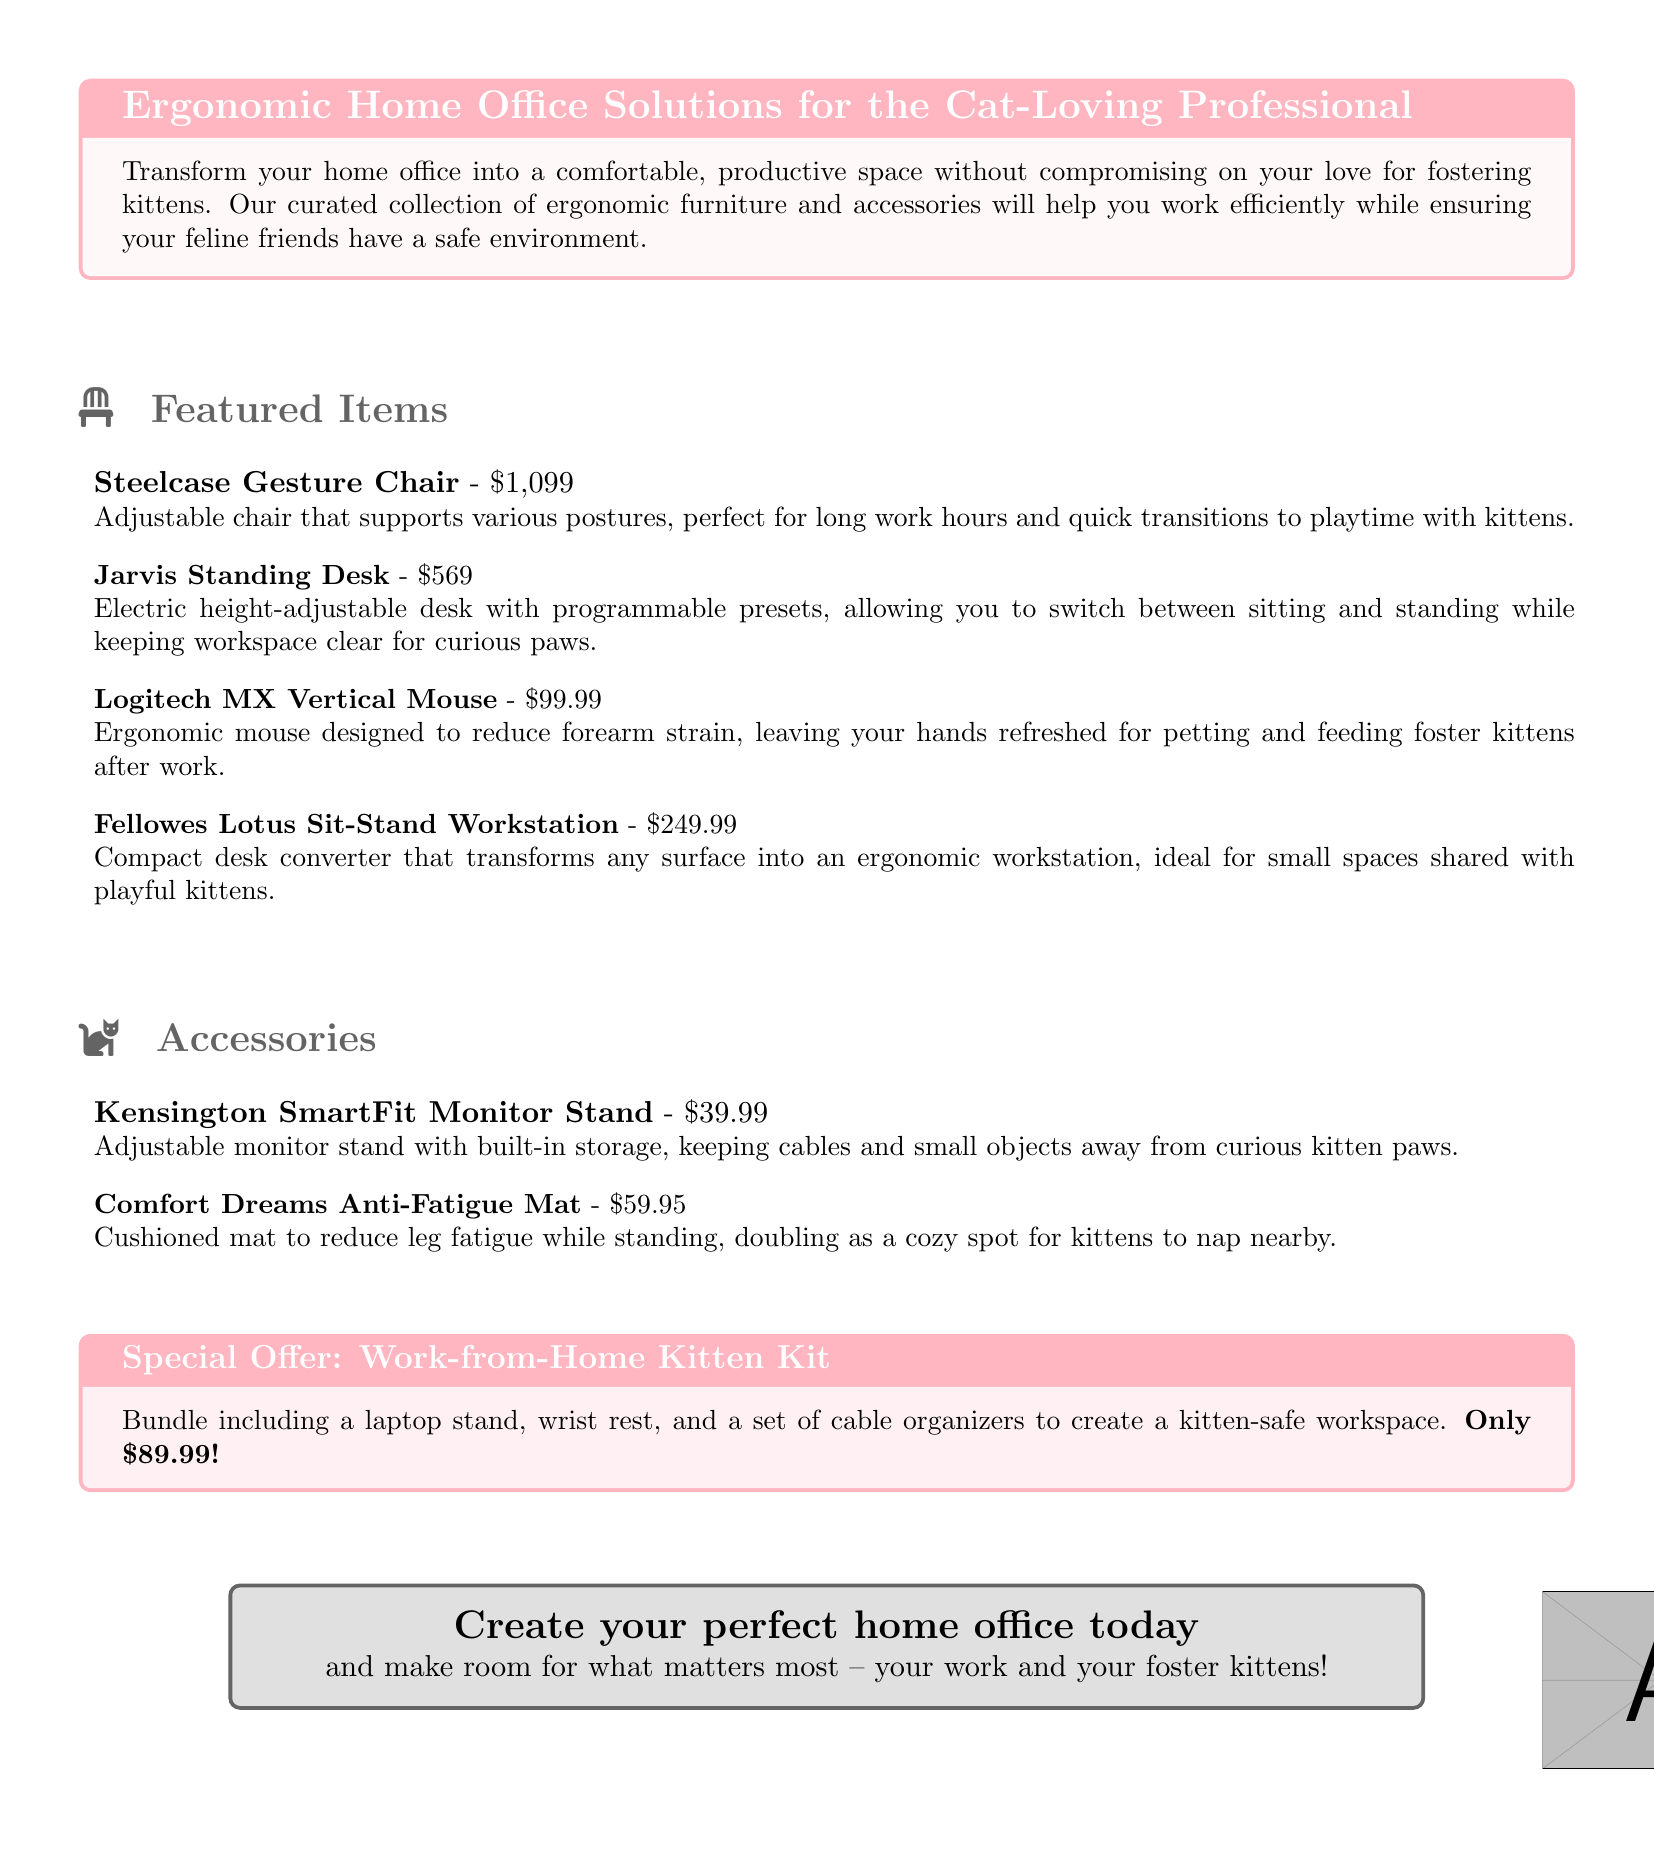What is the price of the Steelcase Gesture Chair? The price is listed directly next to the item description in the document.
Answer: $1,099 What does the Jarvis Standing Desk offer? The document states it is an electric height-adjustable desk with programmable presets.
Answer: Electric height-adjustable desk What is included in the special offer? The document mentions the contents of the special offer, which are specified.
Answer: Laptop stand, wrist rest, cable organizers What type of ergonomic accessory is the Kensington SmartFit? The document describes it in terms of its function and features.
Answer: Monitor stand How much does the Comfort Dreams Anti-Fatigue Mat cost? The price is provided alongside the item in the accessories section of the document.
Answer: $59.95 What is the purpose of the Fellowes Lotus Sit-Stand Workstation? The document explains the primary function of this item.
Answer: Transforms any surface into an ergonomic workstation How does the Logitech MX Vertical Mouse benefit users? The document discusses the ergonomic design's advantages, specifically for users' hands.
Answer: Reduce forearm strain What color theme is used for the document's title boxes? The color descriptions are provided in the document’s formatting instructions.
Answer: Cat pink How are the kitten kits priced? The document provides the price as part of the offer description.
Answer: Only $89.99 